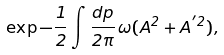<formula> <loc_0><loc_0><loc_500><loc_500>\exp { - \frac { 1 } { 2 } \int \frac { d p } { 2 \pi } \, \omega ( A ^ { 2 } + A ^ { ^ { \prime } 2 } ) } ,</formula> 